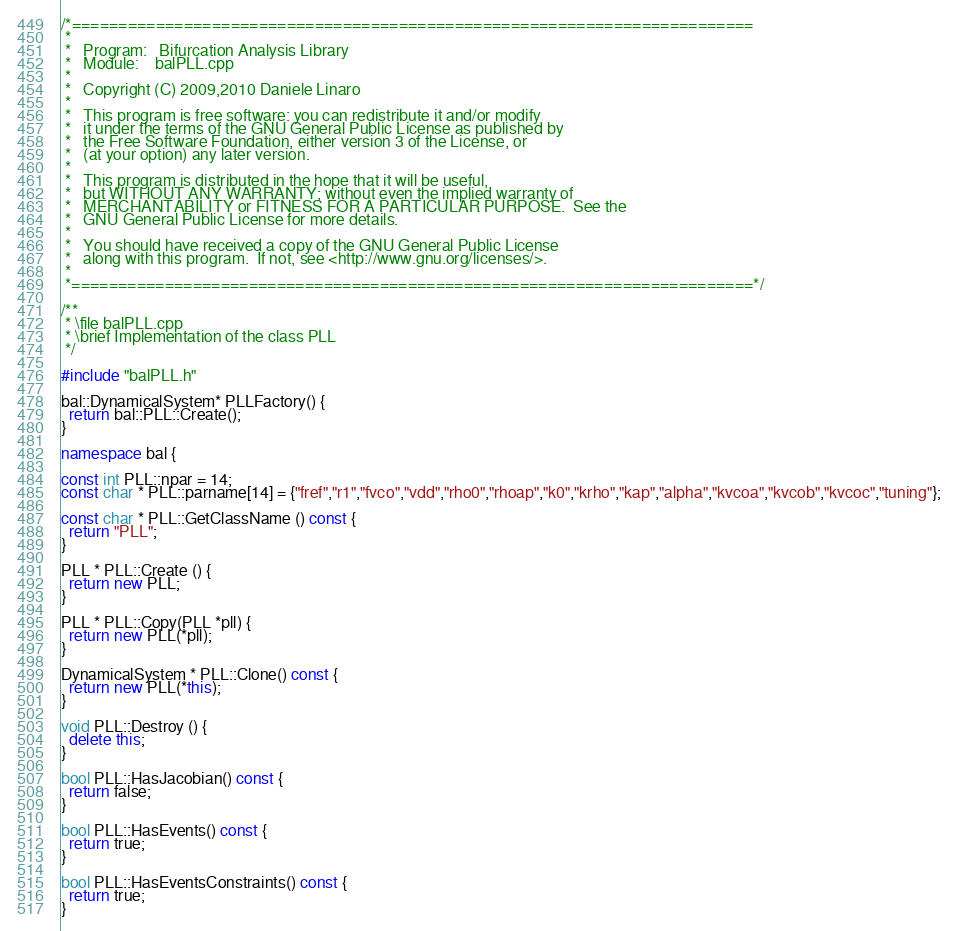<code> <loc_0><loc_0><loc_500><loc_500><_C++_>/*=========================================================================
 *
 *   Program:   Bifurcation Analysis Library
 *   Module:    balPLL.cpp
 *
 *   Copyright (C) 2009,2010 Daniele Linaro
 *
 *   This program is free software: you can redistribute it and/or modify
 *   it under the terms of the GNU General Public License as published by
 *   the Free Software Foundation, either version 3 of the License, or
 *   (at your option) any later version.
 *   
 *   This program is distributed in the hope that it will be useful,
 *   but WITHOUT ANY WARRANTY; without even the implied warranty of
 *   MERCHANTABILITY or FITNESS FOR A PARTICULAR PURPOSE.  See the
 *   GNU General Public License for more details.
 *   
 *   You should have received a copy of the GNU General Public License
 *   along with this program.  If not, see <http://www.gnu.org/licenses/>.
 *
 *=========================================================================*/

/** 
 * \file balPLL.cpp
 * \brief Implementation of the class PLL
 */

#include "balPLL.h"

bal::DynamicalSystem* PLLFactory() {
  return bal::PLL::Create();
}

namespace bal {

const int PLL::npar = 14;
const char * PLL::parname[14] = {"fref","r1","fvco","vdd","rho0","rhoap","k0","krho","kap","alpha","kvcoa","kvcob","kvcoc","tuning"};

const char * PLL::GetClassName () const {
  return "PLL";
}

PLL * PLL::Create () {
  return new PLL;
}

PLL * PLL::Copy(PLL *pll) {
  return new PLL(*pll);
}

DynamicalSystem * PLL::Clone() const {
  return new PLL(*this);
}

void PLL::Destroy () {
  delete this;
}

bool PLL::HasJacobian() const {
  return false;
}

bool PLL::HasEvents() const {
  return true;
}

bool PLL::HasEventsConstraints() const {
  return true;
}
</code> 